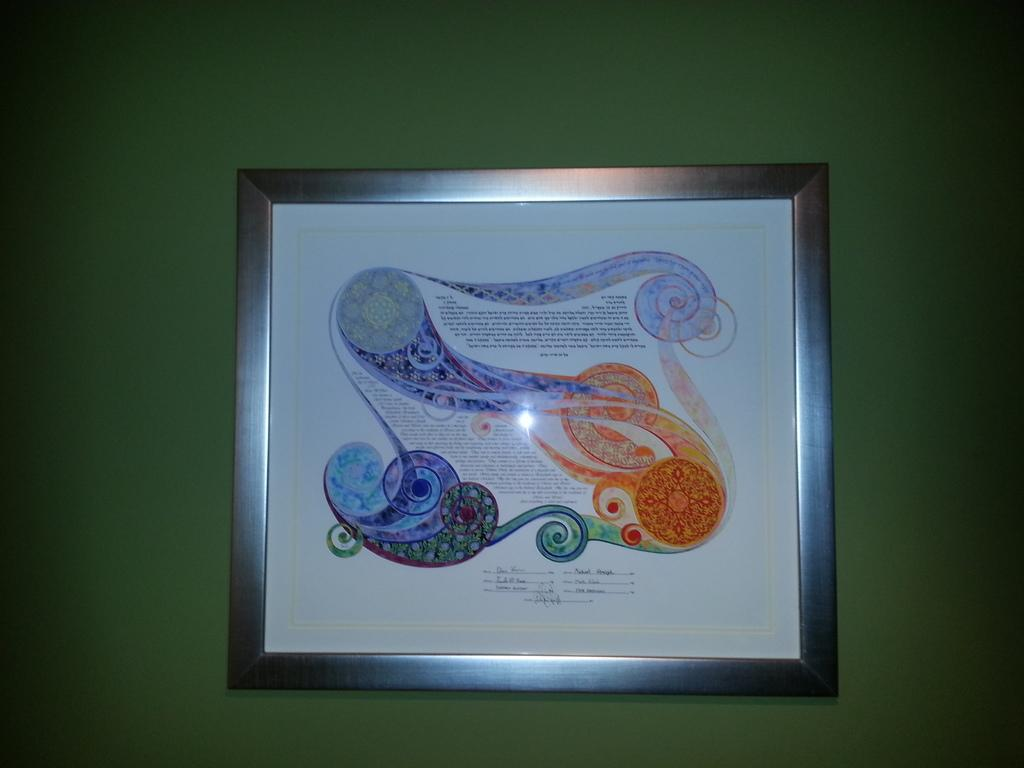What is the main object in the center of the image? There is a photo frame in the center of the image. Where is the photo frame located? The photo frame is on a wall. What can be seen on the photo frame? There is text on the photo frame. Is there a carriage being washed with a toothbrush in the image? No, there is no carriage or toothbrush present in the image. 